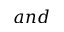Convert formula to latex. <formula><loc_0><loc_0><loc_500><loc_500>a n d</formula> 